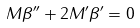<formula> <loc_0><loc_0><loc_500><loc_500>M \beta ^ { \prime \prime } + 2 M ^ { \prime } \beta ^ { \prime } = 0</formula> 